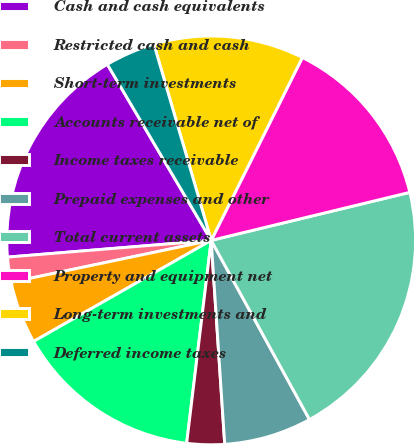<chart> <loc_0><loc_0><loc_500><loc_500><pie_chart><fcel>Cash and cash equivalents<fcel>Restricted cash and cash<fcel>Short-term investments<fcel>Accounts receivable net of<fcel>Income taxes receivable<fcel>Prepaid expenses and other<fcel>Total current assets<fcel>Property and equipment net<fcel>Long-term investments and<fcel>Deferred income taxes<nl><fcel>17.82%<fcel>1.98%<fcel>4.95%<fcel>14.85%<fcel>2.97%<fcel>6.93%<fcel>20.79%<fcel>13.86%<fcel>11.88%<fcel>3.96%<nl></chart> 